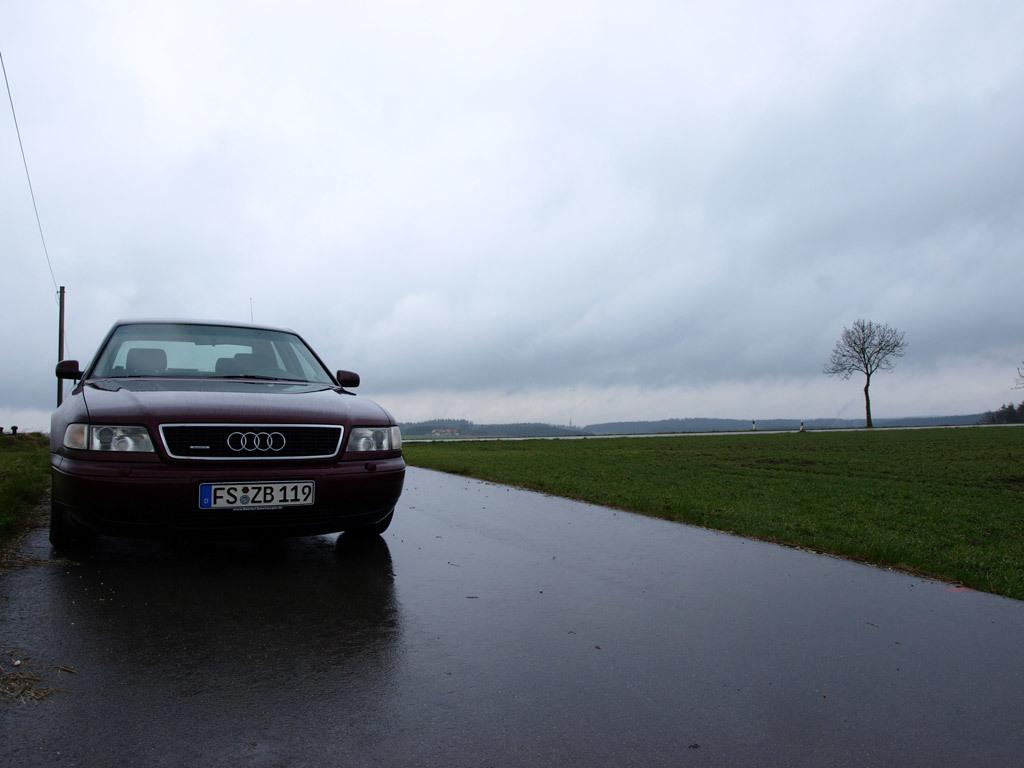<image>
Describe the image concisely. An Audi with a liscence plate reading FS ZB 119. 